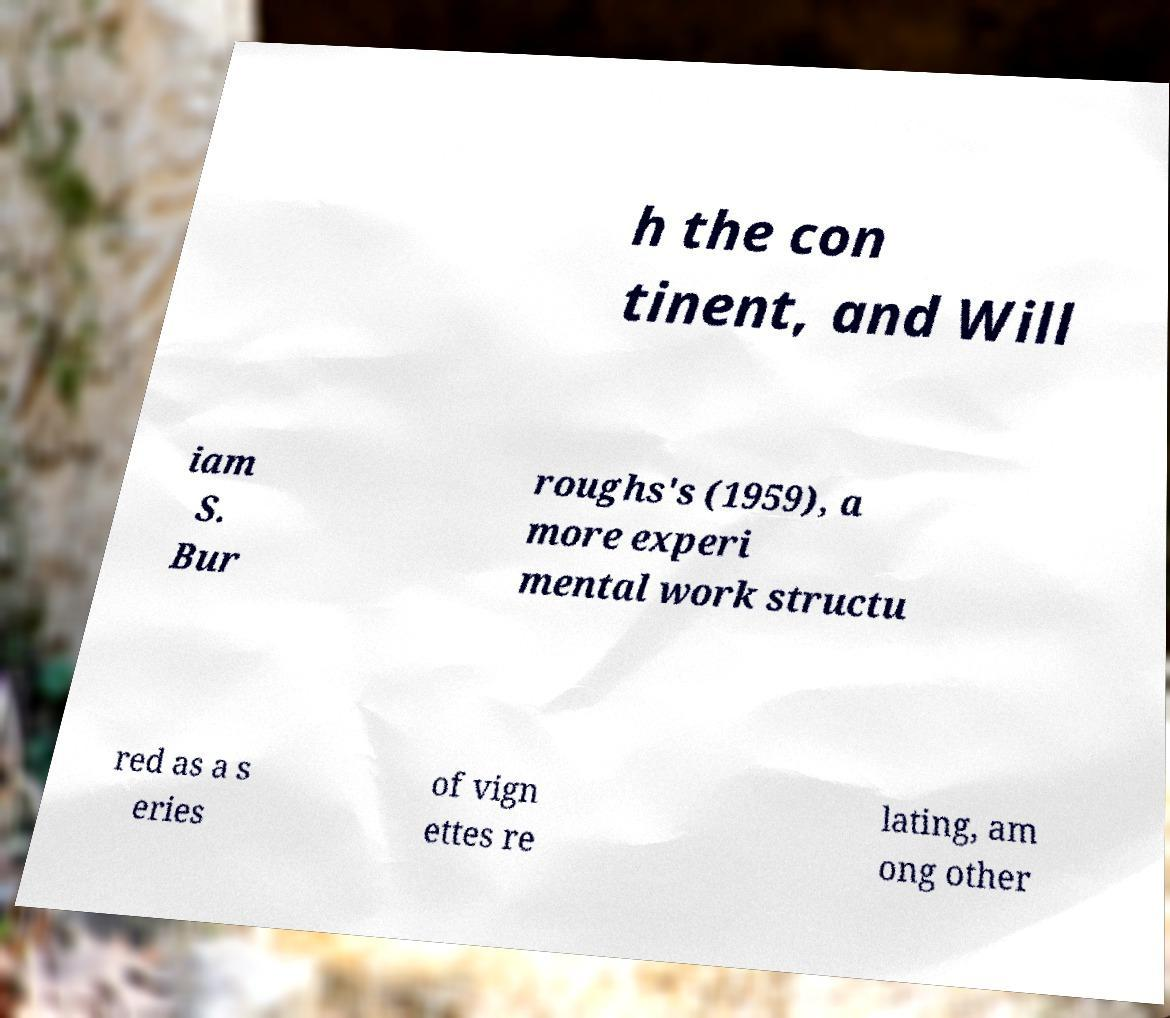Could you extract and type out the text from this image? h the con tinent, and Will iam S. Bur roughs's (1959), a more experi mental work structu red as a s eries of vign ettes re lating, am ong other 